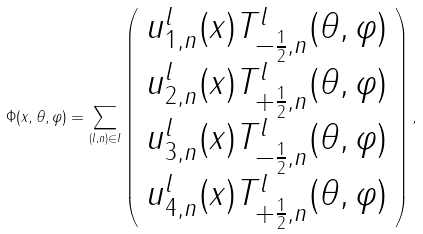<formula> <loc_0><loc_0><loc_500><loc_500>\Phi ( x , \theta , \varphi ) = \sum _ { ( l , n ) \in I } \left ( \begin{array} { c } u ^ { l } _ { 1 , n } ( x ) T ^ { l } _ { - \frac { 1 } { 2 } , n } ( \theta , \varphi ) \\ u ^ { l } _ { 2 , n } ( x ) T ^ { l } _ { + \frac { 1 } { 2 } , n } ( \theta , \varphi ) \\ u ^ { l } _ { 3 , n } ( x ) T ^ { l } _ { - \frac { 1 } { 2 } , n } ( \theta , \varphi ) \\ u ^ { l } _ { 4 , n } ( x ) T ^ { l } _ { + \frac { 1 } { 2 } , n } ( \theta , \varphi ) \end{array} \right ) ,</formula> 